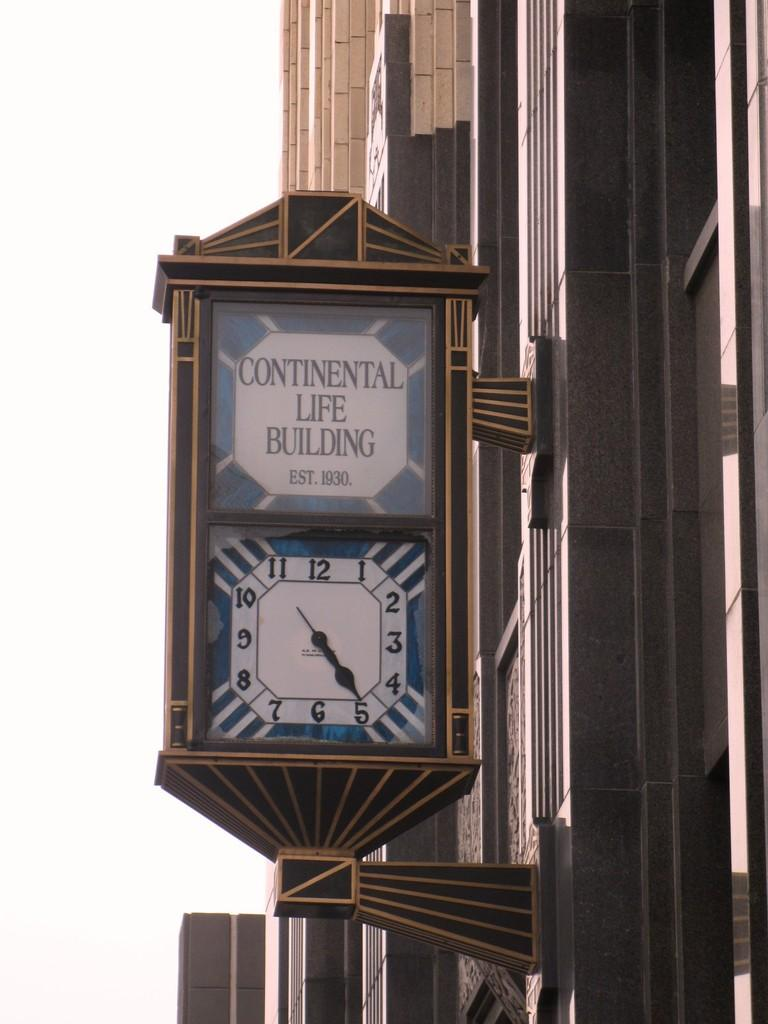<image>
Provide a brief description of the given image. A clock sticks out from the wall of the Continental Life Building. 